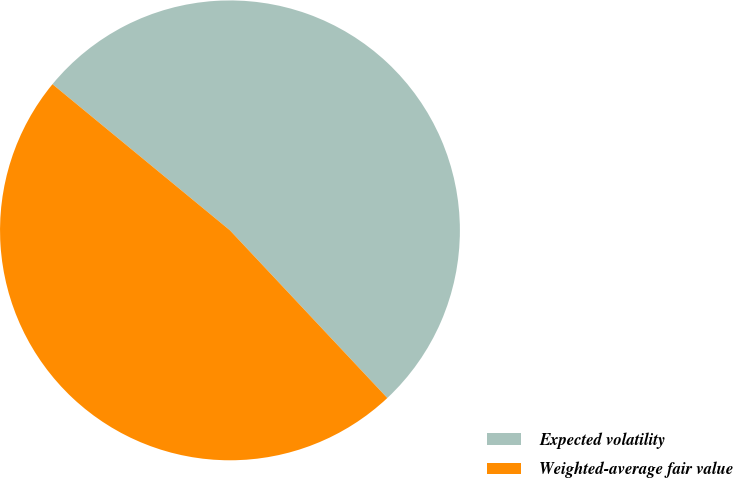Convert chart. <chart><loc_0><loc_0><loc_500><loc_500><pie_chart><fcel>Expected volatility<fcel>Weighted-average fair value<nl><fcel>52.04%<fcel>47.96%<nl></chart> 